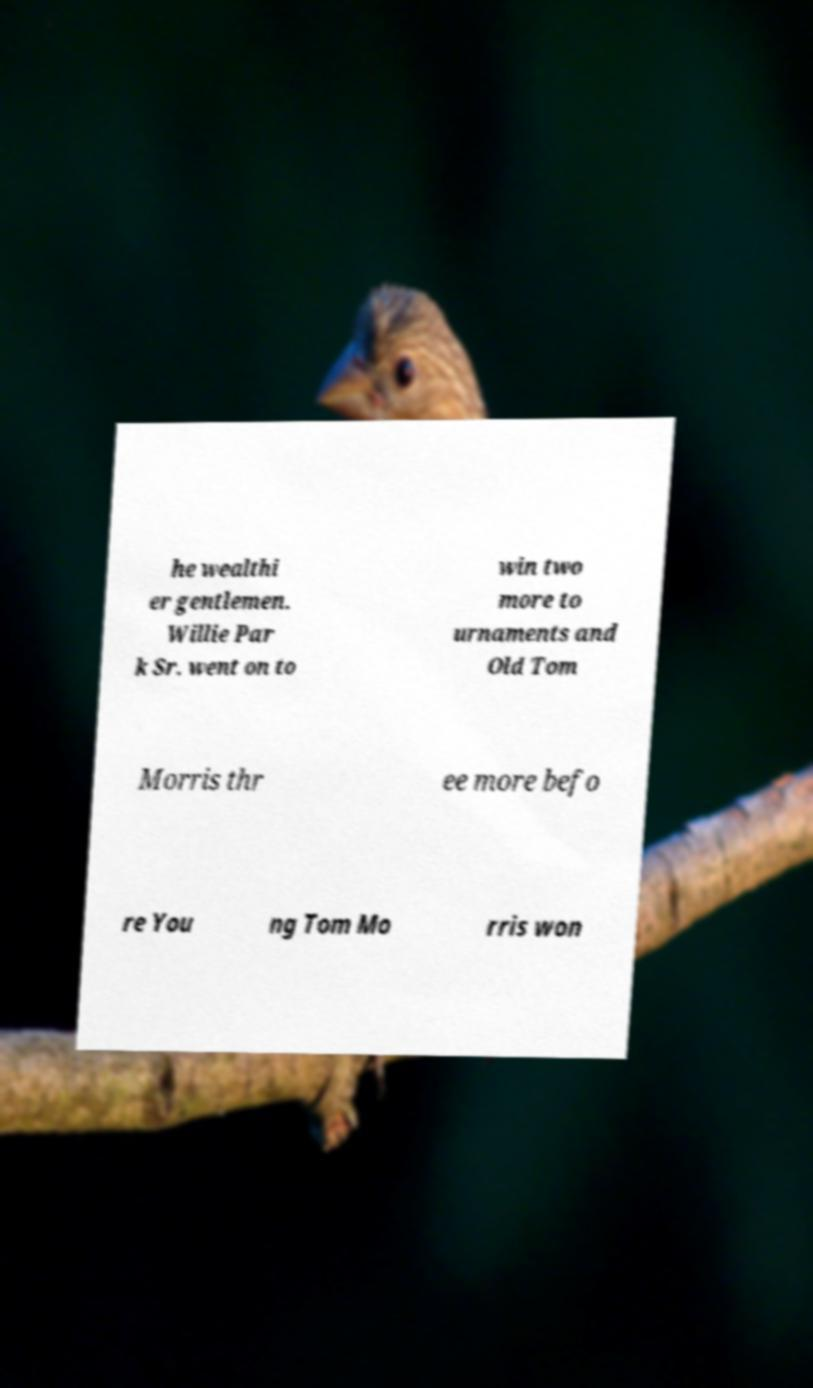Could you assist in decoding the text presented in this image and type it out clearly? he wealthi er gentlemen. Willie Par k Sr. went on to win two more to urnaments and Old Tom Morris thr ee more befo re You ng Tom Mo rris won 